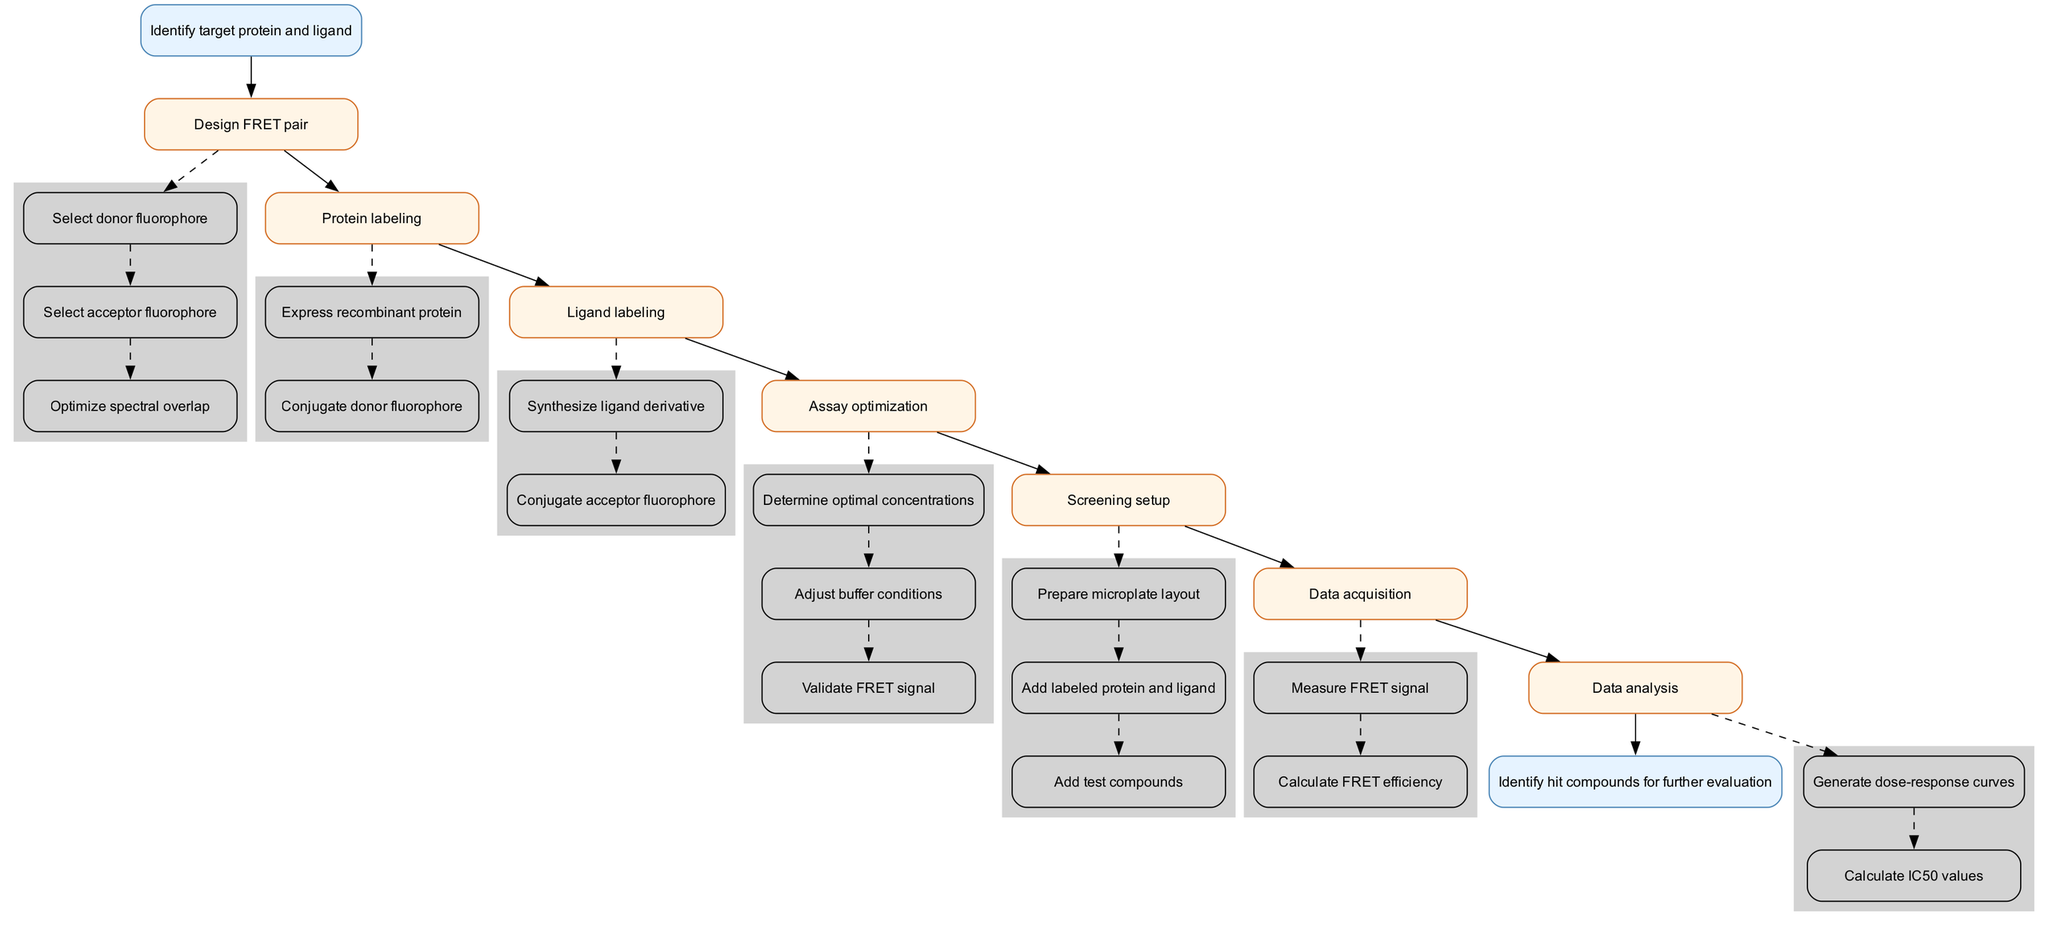What is the first step in the protocol? The first step listed in the diagram is "Identify target protein and ligand," which is indicated at the top of the flowchart as the starting point of the process.
Answer: Identify target protein and ligand How many main steps are present in the protocol? Upon reviewing the diagram, I count a total of seven main steps listed in the protocol, ranging from the design of the FRET pair to data analysis.
Answer: Seven What is the last step before identifying hit compounds? The last step before reaching the endpoint is "Data analysis," which directly precedes the final step in the flowchart.
Answer: Data analysis Which substep follows the "Express recombinant protein" in the Protein labeling step? The substep immediately following "Express recombinant protein" is "Conjugate donor fluorophore," as the substeps flow sequentially from one to the next.
Answer: Conjugate donor fluorophore What is required for optimal assay conditions? "Determine optimal concentrations" is necessary for adjusting the assay conditions, as it's a substep within "Assay optimization," helping to maximize the assay performance.
Answer: Determine optimal concentrations What is the connection between "Ligand labeling" and "Screening setup"? "Ligand labeling" leads directly into the next major step, "Screening setup," indicating that the preparation of the ligand is essential before proceeding to set up the screening experiment.
Answer: Direct connection Which substep validates FRET signal? The substep responsible for validating the FRET signal is "Validate FRET signal," found under the "Assay optimization" step of the protocol.
Answer: Validate FRET signal What type of curves are generated in the data analysis step? During the "Data analysis," "Generate dose-response curves" is specifically mentioned, indicating the type of analysis conducted with the data collected.
Answer: Dose-response curves How do you measure FRET efficiency? "Calculate FRET efficiency" is the action performed during the "Data acquisition" step to compute FRET efficiency based on measured signals from the assay.
Answer: Calculate FRET efficiency 